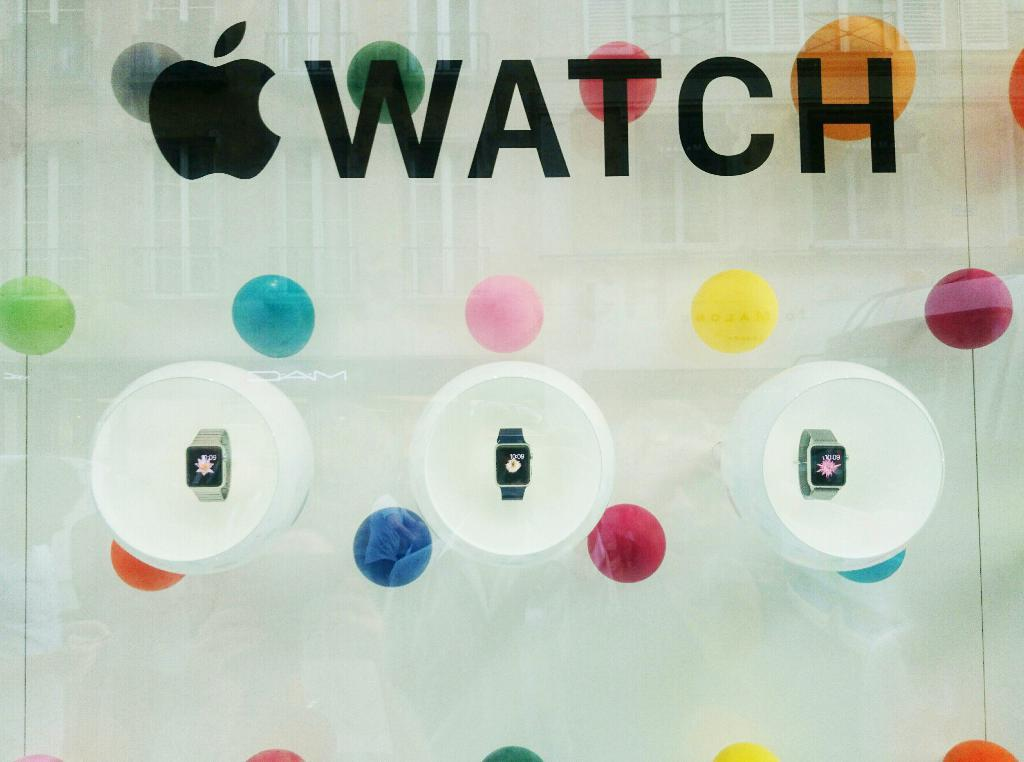What type of objects can be seen in the image? There are watches in the image. Can you describe any additional features of the image? There is text on the glass in the image. How many lizards can be seen climbing on the watches in the image? There are no lizards present in the image; it only features watches and text on the glass. 